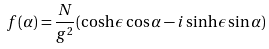<formula> <loc_0><loc_0><loc_500><loc_500>f ( \alpha ) = \frac { N } { g ^ { 2 } } ( \cosh \epsilon \cos \alpha - i \sinh \epsilon \sin \alpha )</formula> 